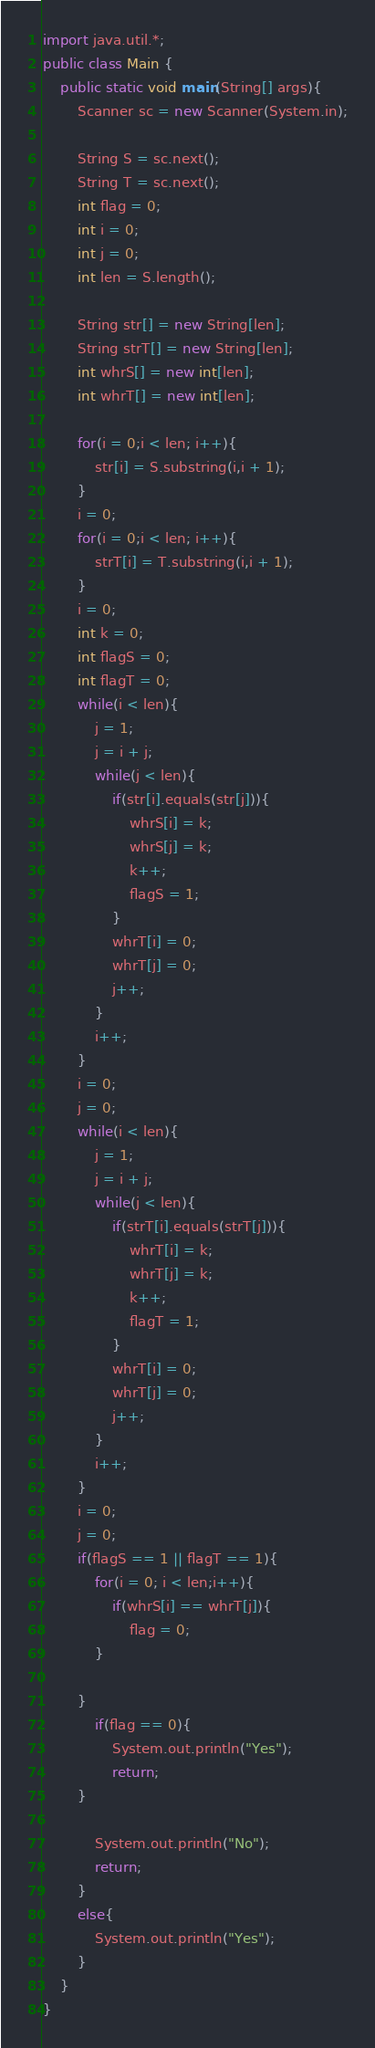<code> <loc_0><loc_0><loc_500><loc_500><_Java_>import java.util.*;
public class Main {
	public static void main(String[] args){
		Scanner sc = new Scanner(System.in);
		
		String S = sc.next();
		String T = sc.next();
		int flag = 0;
		int i = 0;
		int j = 0;
		int len = S.length();
		
		String str[] = new String[len];
		String strT[] = new String[len];
		int whrS[] = new int[len];
		int whrT[] = new int[len];
		
		for(i = 0;i < len; i++){
			str[i] = S.substring(i,i + 1);
		}
		i = 0;
		for(i = 0;i < len; i++){
			strT[i] = T.substring(i,i + 1);
		}
		i = 0;
		int k = 0;
		int flagS = 0;
		int flagT = 0;
		while(i < len){
			j = 1;
			j = i + j;
			while(j < len){
				if(str[i].equals(str[j])){
					whrS[i] = k;
					whrS[j] = k;
					k++;
					flagS = 1;
				}
				whrT[i] = 0;
				whrT[j] = 0;
				j++;
			}
			i++;
		}
		i = 0;
		j = 0;
		while(i < len){
			j = 1;
			j = i + j;
			while(j < len){
				if(strT[i].equals(strT[j])){
					whrT[i] = k;
					whrT[j] = k;
					k++;
					flagT = 1;
				}
				whrT[i] = 0;
				whrT[j] = 0;
				j++;
			}
			i++;
		}
		i = 0;
		j = 0;
		if(flagS == 1 || flagT == 1){
			for(i = 0; i < len;i++){
				if(whrS[i] == whrT[j]){
					flag = 0;
			}
				
		}
			if(flag == 0){
				System.out.println("Yes");
				return;
		}
			
			System.out.println("No");
			return;
		}
		else{
			System.out.println("Yes");
		}
	}
}</code> 